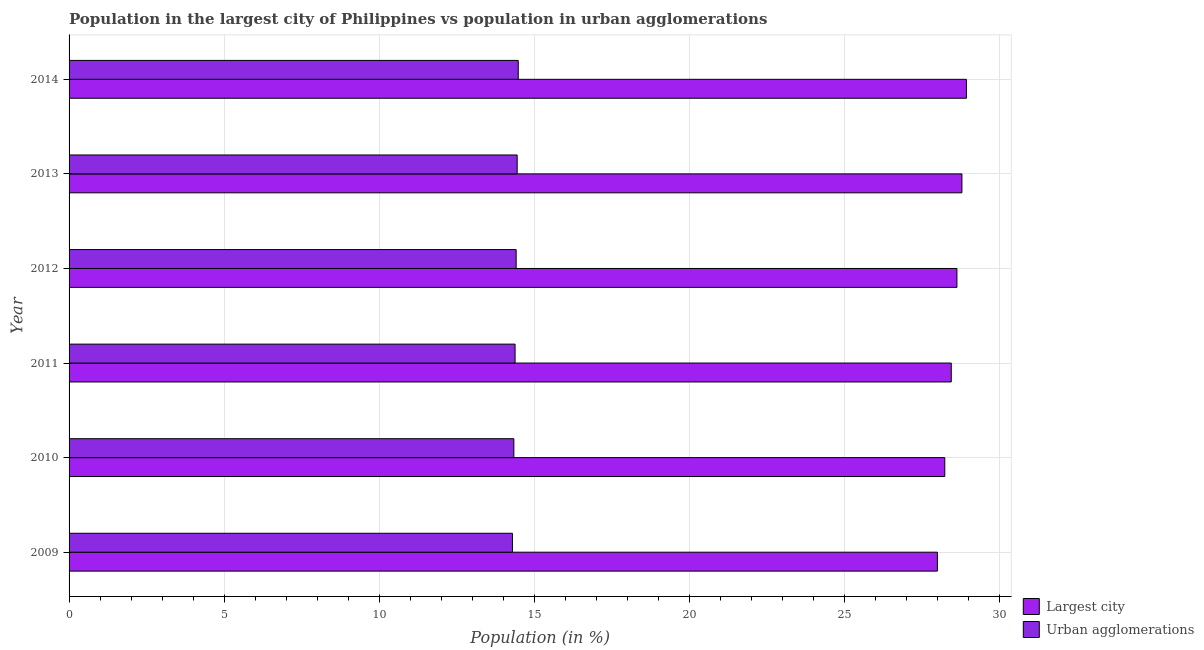How many groups of bars are there?
Offer a very short reply. 6. Are the number of bars on each tick of the Y-axis equal?
Your response must be concise. Yes. How many bars are there on the 6th tick from the bottom?
Give a very brief answer. 2. In how many cases, is the number of bars for a given year not equal to the number of legend labels?
Your response must be concise. 0. What is the population in urban agglomerations in 2010?
Keep it short and to the point. 14.34. Across all years, what is the maximum population in the largest city?
Your response must be concise. 28.94. Across all years, what is the minimum population in urban agglomerations?
Ensure brevity in your answer.  14.3. What is the total population in urban agglomerations in the graph?
Give a very brief answer. 86.38. What is the difference between the population in the largest city in 2010 and that in 2014?
Keep it short and to the point. -0.7. What is the difference between the population in the largest city in 2009 and the population in urban agglomerations in 2012?
Provide a short and direct response. 13.58. What is the average population in the largest city per year?
Give a very brief answer. 28.51. In the year 2012, what is the difference between the population in the largest city and population in urban agglomerations?
Offer a terse response. 14.21. In how many years, is the population in urban agglomerations greater than 6 %?
Make the answer very short. 6. Is the population in the largest city in 2009 less than that in 2010?
Offer a very short reply. Yes. What is the difference between the highest and the second highest population in the largest city?
Offer a terse response. 0.14. What is the difference between the highest and the lowest population in urban agglomerations?
Ensure brevity in your answer.  0.19. What does the 1st bar from the top in 2009 represents?
Your response must be concise. Urban agglomerations. What does the 1st bar from the bottom in 2012 represents?
Your answer should be compact. Largest city. How many bars are there?
Provide a short and direct response. 12. How many years are there in the graph?
Your answer should be very brief. 6. Does the graph contain any zero values?
Make the answer very short. No. Does the graph contain grids?
Offer a very short reply. Yes. Where does the legend appear in the graph?
Provide a short and direct response. Bottom right. How are the legend labels stacked?
Provide a short and direct response. Vertical. What is the title of the graph?
Provide a succinct answer. Population in the largest city of Philippines vs population in urban agglomerations. Does "Highest 10% of population" appear as one of the legend labels in the graph?
Your response must be concise. No. What is the label or title of the Y-axis?
Provide a succinct answer. Year. What is the Population (in %) of Largest city in 2009?
Offer a very short reply. 28. What is the Population (in %) in Urban agglomerations in 2009?
Provide a short and direct response. 14.3. What is the Population (in %) of Largest city in 2010?
Give a very brief answer. 28.24. What is the Population (in %) of Urban agglomerations in 2010?
Keep it short and to the point. 14.34. What is the Population (in %) in Largest city in 2011?
Your answer should be very brief. 28.45. What is the Population (in %) in Urban agglomerations in 2011?
Your answer should be very brief. 14.38. What is the Population (in %) in Largest city in 2012?
Ensure brevity in your answer.  28.63. What is the Population (in %) in Urban agglomerations in 2012?
Provide a succinct answer. 14.42. What is the Population (in %) in Largest city in 2013?
Keep it short and to the point. 28.79. What is the Population (in %) of Urban agglomerations in 2013?
Provide a short and direct response. 14.45. What is the Population (in %) in Largest city in 2014?
Make the answer very short. 28.94. What is the Population (in %) in Urban agglomerations in 2014?
Give a very brief answer. 14.49. Across all years, what is the maximum Population (in %) of Largest city?
Offer a terse response. 28.94. Across all years, what is the maximum Population (in %) in Urban agglomerations?
Provide a short and direct response. 14.49. Across all years, what is the minimum Population (in %) of Largest city?
Provide a short and direct response. 28. Across all years, what is the minimum Population (in %) in Urban agglomerations?
Make the answer very short. 14.3. What is the total Population (in %) of Largest city in the graph?
Ensure brevity in your answer.  171.06. What is the total Population (in %) in Urban agglomerations in the graph?
Your response must be concise. 86.38. What is the difference between the Population (in %) of Largest city in 2009 and that in 2010?
Give a very brief answer. -0.24. What is the difference between the Population (in %) in Urban agglomerations in 2009 and that in 2010?
Ensure brevity in your answer.  -0.05. What is the difference between the Population (in %) in Largest city in 2009 and that in 2011?
Offer a terse response. -0.45. What is the difference between the Population (in %) in Urban agglomerations in 2009 and that in 2011?
Provide a short and direct response. -0.09. What is the difference between the Population (in %) of Largest city in 2009 and that in 2012?
Offer a very short reply. -0.63. What is the difference between the Population (in %) in Urban agglomerations in 2009 and that in 2012?
Provide a short and direct response. -0.12. What is the difference between the Population (in %) in Largest city in 2009 and that in 2013?
Your answer should be compact. -0.79. What is the difference between the Population (in %) in Urban agglomerations in 2009 and that in 2013?
Offer a very short reply. -0.15. What is the difference between the Population (in %) of Largest city in 2009 and that in 2014?
Ensure brevity in your answer.  -0.94. What is the difference between the Population (in %) in Urban agglomerations in 2009 and that in 2014?
Your answer should be compact. -0.19. What is the difference between the Population (in %) of Largest city in 2010 and that in 2011?
Keep it short and to the point. -0.21. What is the difference between the Population (in %) in Urban agglomerations in 2010 and that in 2011?
Your answer should be very brief. -0.04. What is the difference between the Population (in %) of Largest city in 2010 and that in 2012?
Give a very brief answer. -0.39. What is the difference between the Population (in %) of Urban agglomerations in 2010 and that in 2012?
Your response must be concise. -0.07. What is the difference between the Population (in %) in Largest city in 2010 and that in 2013?
Your answer should be very brief. -0.55. What is the difference between the Population (in %) of Urban agglomerations in 2010 and that in 2013?
Your answer should be compact. -0.11. What is the difference between the Population (in %) in Largest city in 2010 and that in 2014?
Your answer should be compact. -0.7. What is the difference between the Population (in %) of Urban agglomerations in 2010 and that in 2014?
Provide a short and direct response. -0.14. What is the difference between the Population (in %) in Largest city in 2011 and that in 2012?
Your answer should be compact. -0.18. What is the difference between the Population (in %) in Urban agglomerations in 2011 and that in 2012?
Your answer should be very brief. -0.03. What is the difference between the Population (in %) of Largest city in 2011 and that in 2013?
Your response must be concise. -0.34. What is the difference between the Population (in %) of Urban agglomerations in 2011 and that in 2013?
Provide a succinct answer. -0.07. What is the difference between the Population (in %) of Largest city in 2011 and that in 2014?
Keep it short and to the point. -0.49. What is the difference between the Population (in %) of Urban agglomerations in 2011 and that in 2014?
Your response must be concise. -0.1. What is the difference between the Population (in %) in Largest city in 2012 and that in 2013?
Give a very brief answer. -0.16. What is the difference between the Population (in %) of Urban agglomerations in 2012 and that in 2013?
Keep it short and to the point. -0.03. What is the difference between the Population (in %) in Largest city in 2012 and that in 2014?
Offer a very short reply. -0.31. What is the difference between the Population (in %) of Urban agglomerations in 2012 and that in 2014?
Offer a terse response. -0.07. What is the difference between the Population (in %) in Largest city in 2013 and that in 2014?
Keep it short and to the point. -0.15. What is the difference between the Population (in %) of Urban agglomerations in 2013 and that in 2014?
Your answer should be compact. -0.03. What is the difference between the Population (in %) in Largest city in 2009 and the Population (in %) in Urban agglomerations in 2010?
Offer a very short reply. 13.66. What is the difference between the Population (in %) in Largest city in 2009 and the Population (in %) in Urban agglomerations in 2011?
Give a very brief answer. 13.62. What is the difference between the Population (in %) of Largest city in 2009 and the Population (in %) of Urban agglomerations in 2012?
Your answer should be very brief. 13.58. What is the difference between the Population (in %) in Largest city in 2009 and the Population (in %) in Urban agglomerations in 2013?
Your answer should be very brief. 13.55. What is the difference between the Population (in %) in Largest city in 2009 and the Population (in %) in Urban agglomerations in 2014?
Give a very brief answer. 13.52. What is the difference between the Population (in %) in Largest city in 2010 and the Population (in %) in Urban agglomerations in 2011?
Give a very brief answer. 13.86. What is the difference between the Population (in %) of Largest city in 2010 and the Population (in %) of Urban agglomerations in 2012?
Give a very brief answer. 13.82. What is the difference between the Population (in %) in Largest city in 2010 and the Population (in %) in Urban agglomerations in 2013?
Offer a terse response. 13.79. What is the difference between the Population (in %) in Largest city in 2010 and the Population (in %) in Urban agglomerations in 2014?
Provide a short and direct response. 13.76. What is the difference between the Population (in %) of Largest city in 2011 and the Population (in %) of Urban agglomerations in 2012?
Offer a terse response. 14.03. What is the difference between the Population (in %) of Largest city in 2011 and the Population (in %) of Urban agglomerations in 2013?
Ensure brevity in your answer.  14. What is the difference between the Population (in %) in Largest city in 2011 and the Population (in %) in Urban agglomerations in 2014?
Give a very brief answer. 13.96. What is the difference between the Population (in %) in Largest city in 2012 and the Population (in %) in Urban agglomerations in 2013?
Offer a terse response. 14.18. What is the difference between the Population (in %) in Largest city in 2012 and the Population (in %) in Urban agglomerations in 2014?
Give a very brief answer. 14.15. What is the difference between the Population (in %) of Largest city in 2013 and the Population (in %) of Urban agglomerations in 2014?
Offer a very short reply. 14.31. What is the average Population (in %) in Largest city per year?
Offer a terse response. 28.51. What is the average Population (in %) in Urban agglomerations per year?
Give a very brief answer. 14.4. In the year 2009, what is the difference between the Population (in %) in Largest city and Population (in %) in Urban agglomerations?
Ensure brevity in your answer.  13.7. In the year 2010, what is the difference between the Population (in %) of Largest city and Population (in %) of Urban agglomerations?
Your answer should be compact. 13.9. In the year 2011, what is the difference between the Population (in %) in Largest city and Population (in %) in Urban agglomerations?
Offer a very short reply. 14.07. In the year 2012, what is the difference between the Population (in %) of Largest city and Population (in %) of Urban agglomerations?
Keep it short and to the point. 14.21. In the year 2013, what is the difference between the Population (in %) of Largest city and Population (in %) of Urban agglomerations?
Give a very brief answer. 14.34. In the year 2014, what is the difference between the Population (in %) of Largest city and Population (in %) of Urban agglomerations?
Ensure brevity in your answer.  14.45. What is the ratio of the Population (in %) of Largest city in 2009 to that in 2010?
Provide a short and direct response. 0.99. What is the ratio of the Population (in %) of Largest city in 2009 to that in 2011?
Keep it short and to the point. 0.98. What is the ratio of the Population (in %) of Largest city in 2009 to that in 2013?
Keep it short and to the point. 0.97. What is the ratio of the Population (in %) in Urban agglomerations in 2009 to that in 2013?
Offer a very short reply. 0.99. What is the ratio of the Population (in %) of Largest city in 2009 to that in 2014?
Keep it short and to the point. 0.97. What is the ratio of the Population (in %) of Urban agglomerations in 2009 to that in 2014?
Offer a very short reply. 0.99. What is the ratio of the Population (in %) of Largest city in 2010 to that in 2011?
Your response must be concise. 0.99. What is the ratio of the Population (in %) in Urban agglomerations in 2010 to that in 2011?
Provide a short and direct response. 1. What is the ratio of the Population (in %) in Largest city in 2010 to that in 2012?
Offer a very short reply. 0.99. What is the ratio of the Population (in %) in Largest city in 2010 to that in 2013?
Your answer should be compact. 0.98. What is the ratio of the Population (in %) of Urban agglomerations in 2010 to that in 2013?
Your response must be concise. 0.99. What is the ratio of the Population (in %) of Largest city in 2010 to that in 2014?
Offer a terse response. 0.98. What is the ratio of the Population (in %) of Urban agglomerations in 2010 to that in 2014?
Provide a succinct answer. 0.99. What is the ratio of the Population (in %) in Urban agglomerations in 2011 to that in 2013?
Your answer should be very brief. 1. What is the ratio of the Population (in %) of Largest city in 2011 to that in 2014?
Your response must be concise. 0.98. What is the ratio of the Population (in %) in Urban agglomerations in 2011 to that in 2014?
Your answer should be very brief. 0.99. What is the ratio of the Population (in %) of Largest city in 2012 to that in 2013?
Provide a short and direct response. 0.99. What is the ratio of the Population (in %) of Largest city in 2013 to that in 2014?
Ensure brevity in your answer.  0.99. What is the difference between the highest and the second highest Population (in %) in Largest city?
Keep it short and to the point. 0.15. What is the difference between the highest and the second highest Population (in %) of Urban agglomerations?
Your answer should be compact. 0.03. What is the difference between the highest and the lowest Population (in %) in Largest city?
Make the answer very short. 0.94. What is the difference between the highest and the lowest Population (in %) of Urban agglomerations?
Keep it short and to the point. 0.19. 